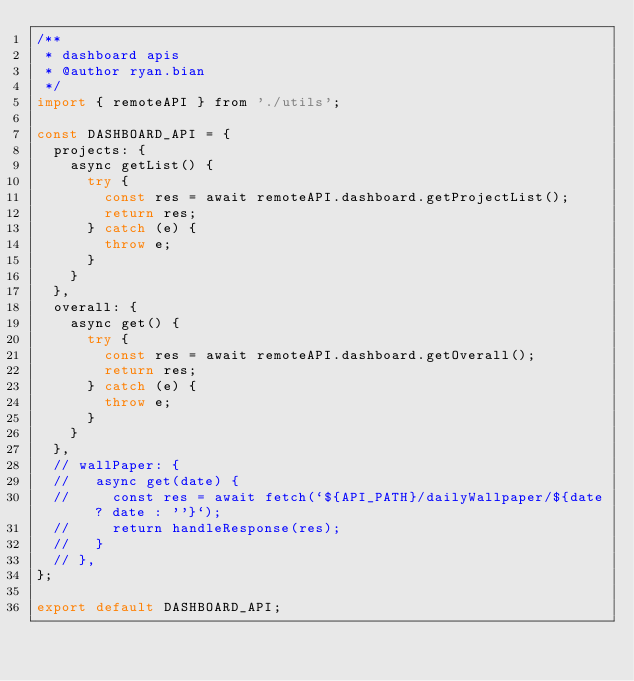<code> <loc_0><loc_0><loc_500><loc_500><_JavaScript_>/**
 * dashboard apis
 * @author ryan.bian
 */
import { remoteAPI } from './utils';

const DASHBOARD_API = {
  projects: {
    async getList() {
      try {
        const res = await remoteAPI.dashboard.getProjectList();
        return res;
      } catch (e) {
        throw e;
      }
    }
  },
  overall: {
    async get() {
      try {
        const res = await remoteAPI.dashboard.getOverall();
        return res;
      } catch (e) {
        throw e;
      }
    }
  },
  // wallPaper: {
  //   async get(date) {
  //     const res = await fetch(`${API_PATH}/dailyWallpaper/${date ? date : ''}`);
  //     return handleResponse(res);
  //   }
  // },
};

export default DASHBOARD_API;
</code> 